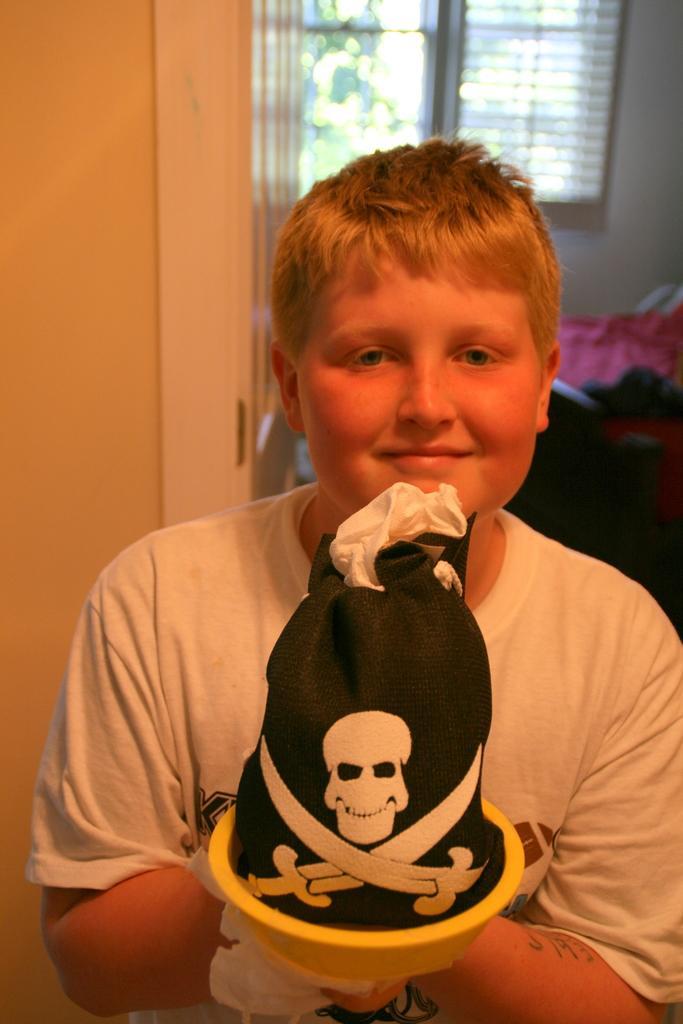Could you give a brief overview of what you see in this image? In this image we can see a person wearing white color T-shirt holding some object in his hands which is wrapped by a black cloth which has danger symbol on it and in the background of the image there is bed, window, curtain and there is a wall. 